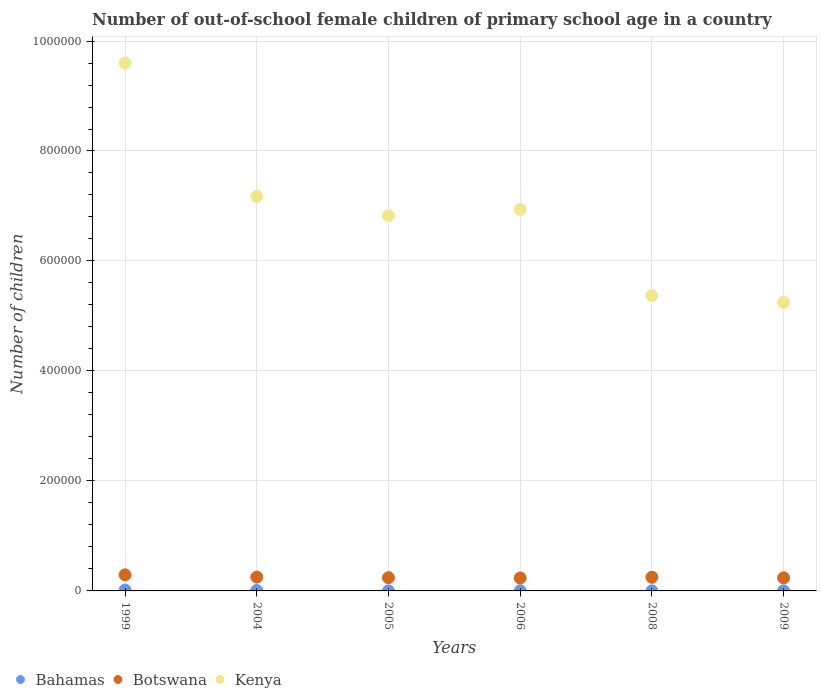Is the number of dotlines equal to the number of legend labels?
Provide a succinct answer. Yes. What is the number of out-of-school female children in Botswana in 2004?
Give a very brief answer. 2.52e+04. Across all years, what is the maximum number of out-of-school female children in Botswana?
Your answer should be compact. 2.92e+04. Across all years, what is the minimum number of out-of-school female children in Botswana?
Give a very brief answer. 2.36e+04. In which year was the number of out-of-school female children in Botswana maximum?
Provide a succinct answer. 1999. In which year was the number of out-of-school female children in Bahamas minimum?
Offer a terse response. 2005. What is the total number of out-of-school female children in Kenya in the graph?
Your answer should be compact. 4.12e+06. What is the difference between the number of out-of-school female children in Bahamas in 1999 and that in 2008?
Offer a very short reply. 1557. What is the difference between the number of out-of-school female children in Bahamas in 2006 and the number of out-of-school female children in Botswana in 2004?
Make the answer very short. -2.49e+04. What is the average number of out-of-school female children in Kenya per year?
Your response must be concise. 6.86e+05. In the year 2006, what is the difference between the number of out-of-school female children in Bahamas and number of out-of-school female children in Botswana?
Your answer should be very brief. -2.33e+04. What is the ratio of the number of out-of-school female children in Bahamas in 2004 to that in 2005?
Your answer should be compact. 34.7. Is the number of out-of-school female children in Kenya in 2004 less than that in 2006?
Keep it short and to the point. No. Is the difference between the number of out-of-school female children in Bahamas in 1999 and 2006 greater than the difference between the number of out-of-school female children in Botswana in 1999 and 2006?
Provide a short and direct response. No. What is the difference between the highest and the second highest number of out-of-school female children in Kenya?
Your answer should be very brief. 2.43e+05. What is the difference between the highest and the lowest number of out-of-school female children in Kenya?
Give a very brief answer. 4.35e+05. In how many years, is the number of out-of-school female children in Kenya greater than the average number of out-of-school female children in Kenya taken over all years?
Your response must be concise. 3. Is the sum of the number of out-of-school female children in Bahamas in 2004 and 2008 greater than the maximum number of out-of-school female children in Kenya across all years?
Offer a terse response. No. Is it the case that in every year, the sum of the number of out-of-school female children in Kenya and number of out-of-school female children in Bahamas  is greater than the number of out-of-school female children in Botswana?
Ensure brevity in your answer.  Yes. Is the number of out-of-school female children in Kenya strictly greater than the number of out-of-school female children in Bahamas over the years?
Make the answer very short. Yes. How many dotlines are there?
Make the answer very short. 3. How many legend labels are there?
Ensure brevity in your answer.  3. What is the title of the graph?
Your answer should be compact. Number of out-of-school female children of primary school age in a country. Does "Egypt, Arab Rep." appear as one of the legend labels in the graph?
Your response must be concise. No. What is the label or title of the X-axis?
Offer a very short reply. Years. What is the label or title of the Y-axis?
Give a very brief answer. Number of children. What is the Number of children in Bahamas in 1999?
Provide a succinct answer. 1607. What is the Number of children in Botswana in 1999?
Keep it short and to the point. 2.92e+04. What is the Number of children of Kenya in 1999?
Offer a terse response. 9.60e+05. What is the Number of children of Bahamas in 2004?
Ensure brevity in your answer.  798. What is the Number of children of Botswana in 2004?
Keep it short and to the point. 2.52e+04. What is the Number of children of Kenya in 2004?
Ensure brevity in your answer.  7.17e+05. What is the Number of children of Botswana in 2005?
Offer a very short reply. 2.40e+04. What is the Number of children of Kenya in 2005?
Your answer should be compact. 6.82e+05. What is the Number of children in Bahamas in 2006?
Offer a terse response. 241. What is the Number of children of Botswana in 2006?
Your answer should be compact. 2.36e+04. What is the Number of children in Kenya in 2006?
Offer a very short reply. 6.94e+05. What is the Number of children in Botswana in 2008?
Offer a very short reply. 2.48e+04. What is the Number of children of Kenya in 2008?
Make the answer very short. 5.37e+05. What is the Number of children of Bahamas in 2009?
Your answer should be very brief. 159. What is the Number of children of Botswana in 2009?
Your answer should be compact. 2.38e+04. What is the Number of children in Kenya in 2009?
Your answer should be very brief. 5.25e+05. Across all years, what is the maximum Number of children in Bahamas?
Ensure brevity in your answer.  1607. Across all years, what is the maximum Number of children in Botswana?
Your answer should be compact. 2.92e+04. Across all years, what is the maximum Number of children of Kenya?
Your response must be concise. 9.60e+05. Across all years, what is the minimum Number of children of Botswana?
Offer a very short reply. 2.36e+04. Across all years, what is the minimum Number of children of Kenya?
Your answer should be very brief. 5.25e+05. What is the total Number of children in Bahamas in the graph?
Give a very brief answer. 2878. What is the total Number of children in Botswana in the graph?
Give a very brief answer. 1.51e+05. What is the total Number of children in Kenya in the graph?
Your response must be concise. 4.12e+06. What is the difference between the Number of children in Bahamas in 1999 and that in 2004?
Offer a very short reply. 809. What is the difference between the Number of children of Botswana in 1999 and that in 2004?
Your response must be concise. 4097. What is the difference between the Number of children in Kenya in 1999 and that in 2004?
Offer a very short reply. 2.43e+05. What is the difference between the Number of children of Bahamas in 1999 and that in 2005?
Offer a very short reply. 1584. What is the difference between the Number of children of Botswana in 1999 and that in 2005?
Make the answer very short. 5205. What is the difference between the Number of children of Kenya in 1999 and that in 2005?
Keep it short and to the point. 2.78e+05. What is the difference between the Number of children of Bahamas in 1999 and that in 2006?
Your response must be concise. 1366. What is the difference between the Number of children in Botswana in 1999 and that in 2006?
Make the answer very short. 5678. What is the difference between the Number of children of Kenya in 1999 and that in 2006?
Keep it short and to the point. 2.66e+05. What is the difference between the Number of children in Bahamas in 1999 and that in 2008?
Ensure brevity in your answer.  1557. What is the difference between the Number of children in Botswana in 1999 and that in 2008?
Ensure brevity in your answer.  4397. What is the difference between the Number of children in Kenya in 1999 and that in 2008?
Ensure brevity in your answer.  4.23e+05. What is the difference between the Number of children of Bahamas in 1999 and that in 2009?
Offer a terse response. 1448. What is the difference between the Number of children of Botswana in 1999 and that in 2009?
Make the answer very short. 5470. What is the difference between the Number of children in Kenya in 1999 and that in 2009?
Your answer should be compact. 4.35e+05. What is the difference between the Number of children in Bahamas in 2004 and that in 2005?
Provide a succinct answer. 775. What is the difference between the Number of children in Botswana in 2004 and that in 2005?
Provide a succinct answer. 1108. What is the difference between the Number of children in Kenya in 2004 and that in 2005?
Your response must be concise. 3.51e+04. What is the difference between the Number of children of Bahamas in 2004 and that in 2006?
Ensure brevity in your answer.  557. What is the difference between the Number of children in Botswana in 2004 and that in 2006?
Give a very brief answer. 1581. What is the difference between the Number of children in Kenya in 2004 and that in 2006?
Give a very brief answer. 2.36e+04. What is the difference between the Number of children in Bahamas in 2004 and that in 2008?
Provide a short and direct response. 748. What is the difference between the Number of children in Botswana in 2004 and that in 2008?
Keep it short and to the point. 300. What is the difference between the Number of children of Kenya in 2004 and that in 2008?
Your answer should be very brief. 1.80e+05. What is the difference between the Number of children of Bahamas in 2004 and that in 2009?
Ensure brevity in your answer.  639. What is the difference between the Number of children in Botswana in 2004 and that in 2009?
Provide a succinct answer. 1373. What is the difference between the Number of children of Kenya in 2004 and that in 2009?
Provide a short and direct response. 1.93e+05. What is the difference between the Number of children of Bahamas in 2005 and that in 2006?
Offer a very short reply. -218. What is the difference between the Number of children in Botswana in 2005 and that in 2006?
Offer a terse response. 473. What is the difference between the Number of children of Kenya in 2005 and that in 2006?
Offer a very short reply. -1.16e+04. What is the difference between the Number of children in Bahamas in 2005 and that in 2008?
Your response must be concise. -27. What is the difference between the Number of children of Botswana in 2005 and that in 2008?
Your answer should be very brief. -808. What is the difference between the Number of children in Kenya in 2005 and that in 2008?
Your response must be concise. 1.45e+05. What is the difference between the Number of children in Bahamas in 2005 and that in 2009?
Your answer should be very brief. -136. What is the difference between the Number of children in Botswana in 2005 and that in 2009?
Give a very brief answer. 265. What is the difference between the Number of children in Kenya in 2005 and that in 2009?
Your answer should be compact. 1.57e+05. What is the difference between the Number of children of Bahamas in 2006 and that in 2008?
Ensure brevity in your answer.  191. What is the difference between the Number of children of Botswana in 2006 and that in 2008?
Provide a short and direct response. -1281. What is the difference between the Number of children of Kenya in 2006 and that in 2008?
Provide a short and direct response. 1.57e+05. What is the difference between the Number of children in Botswana in 2006 and that in 2009?
Provide a succinct answer. -208. What is the difference between the Number of children of Kenya in 2006 and that in 2009?
Give a very brief answer. 1.69e+05. What is the difference between the Number of children in Bahamas in 2008 and that in 2009?
Your answer should be compact. -109. What is the difference between the Number of children of Botswana in 2008 and that in 2009?
Your response must be concise. 1073. What is the difference between the Number of children in Kenya in 2008 and that in 2009?
Provide a succinct answer. 1.22e+04. What is the difference between the Number of children in Bahamas in 1999 and the Number of children in Botswana in 2004?
Your answer should be compact. -2.35e+04. What is the difference between the Number of children in Bahamas in 1999 and the Number of children in Kenya in 2004?
Offer a very short reply. -7.16e+05. What is the difference between the Number of children in Botswana in 1999 and the Number of children in Kenya in 2004?
Make the answer very short. -6.88e+05. What is the difference between the Number of children in Bahamas in 1999 and the Number of children in Botswana in 2005?
Give a very brief answer. -2.24e+04. What is the difference between the Number of children of Bahamas in 1999 and the Number of children of Kenya in 2005?
Your answer should be very brief. -6.81e+05. What is the difference between the Number of children of Botswana in 1999 and the Number of children of Kenya in 2005?
Your response must be concise. -6.53e+05. What is the difference between the Number of children of Bahamas in 1999 and the Number of children of Botswana in 2006?
Keep it short and to the point. -2.20e+04. What is the difference between the Number of children in Bahamas in 1999 and the Number of children in Kenya in 2006?
Your answer should be very brief. -6.92e+05. What is the difference between the Number of children in Botswana in 1999 and the Number of children in Kenya in 2006?
Ensure brevity in your answer.  -6.65e+05. What is the difference between the Number of children of Bahamas in 1999 and the Number of children of Botswana in 2008?
Offer a very short reply. -2.32e+04. What is the difference between the Number of children of Bahamas in 1999 and the Number of children of Kenya in 2008?
Offer a very short reply. -5.35e+05. What is the difference between the Number of children in Botswana in 1999 and the Number of children in Kenya in 2008?
Make the answer very short. -5.08e+05. What is the difference between the Number of children of Bahamas in 1999 and the Number of children of Botswana in 2009?
Your answer should be very brief. -2.22e+04. What is the difference between the Number of children in Bahamas in 1999 and the Number of children in Kenya in 2009?
Provide a succinct answer. -5.23e+05. What is the difference between the Number of children in Botswana in 1999 and the Number of children in Kenya in 2009?
Your answer should be compact. -4.96e+05. What is the difference between the Number of children in Bahamas in 2004 and the Number of children in Botswana in 2005?
Keep it short and to the point. -2.32e+04. What is the difference between the Number of children in Bahamas in 2004 and the Number of children in Kenya in 2005?
Give a very brief answer. -6.81e+05. What is the difference between the Number of children in Botswana in 2004 and the Number of children in Kenya in 2005?
Ensure brevity in your answer.  -6.57e+05. What is the difference between the Number of children in Bahamas in 2004 and the Number of children in Botswana in 2006?
Your response must be concise. -2.28e+04. What is the difference between the Number of children in Bahamas in 2004 and the Number of children in Kenya in 2006?
Offer a very short reply. -6.93e+05. What is the difference between the Number of children in Botswana in 2004 and the Number of children in Kenya in 2006?
Your answer should be very brief. -6.69e+05. What is the difference between the Number of children in Bahamas in 2004 and the Number of children in Botswana in 2008?
Your answer should be compact. -2.41e+04. What is the difference between the Number of children in Bahamas in 2004 and the Number of children in Kenya in 2008?
Give a very brief answer. -5.36e+05. What is the difference between the Number of children in Botswana in 2004 and the Number of children in Kenya in 2008?
Make the answer very short. -5.12e+05. What is the difference between the Number of children in Bahamas in 2004 and the Number of children in Botswana in 2009?
Ensure brevity in your answer.  -2.30e+04. What is the difference between the Number of children of Bahamas in 2004 and the Number of children of Kenya in 2009?
Provide a succinct answer. -5.24e+05. What is the difference between the Number of children of Botswana in 2004 and the Number of children of Kenya in 2009?
Offer a very short reply. -5.00e+05. What is the difference between the Number of children of Bahamas in 2005 and the Number of children of Botswana in 2006?
Give a very brief answer. -2.35e+04. What is the difference between the Number of children of Bahamas in 2005 and the Number of children of Kenya in 2006?
Ensure brevity in your answer.  -6.94e+05. What is the difference between the Number of children of Botswana in 2005 and the Number of children of Kenya in 2006?
Make the answer very short. -6.70e+05. What is the difference between the Number of children of Bahamas in 2005 and the Number of children of Botswana in 2008?
Give a very brief answer. -2.48e+04. What is the difference between the Number of children of Bahamas in 2005 and the Number of children of Kenya in 2008?
Offer a terse response. -5.37e+05. What is the difference between the Number of children in Botswana in 2005 and the Number of children in Kenya in 2008?
Keep it short and to the point. -5.13e+05. What is the difference between the Number of children in Bahamas in 2005 and the Number of children in Botswana in 2009?
Ensure brevity in your answer.  -2.38e+04. What is the difference between the Number of children in Bahamas in 2005 and the Number of children in Kenya in 2009?
Provide a short and direct response. -5.25e+05. What is the difference between the Number of children of Botswana in 2005 and the Number of children of Kenya in 2009?
Offer a very short reply. -5.01e+05. What is the difference between the Number of children in Bahamas in 2006 and the Number of children in Botswana in 2008?
Your response must be concise. -2.46e+04. What is the difference between the Number of children in Bahamas in 2006 and the Number of children in Kenya in 2008?
Make the answer very short. -5.37e+05. What is the difference between the Number of children of Botswana in 2006 and the Number of children of Kenya in 2008?
Keep it short and to the point. -5.13e+05. What is the difference between the Number of children in Bahamas in 2006 and the Number of children in Botswana in 2009?
Offer a very short reply. -2.35e+04. What is the difference between the Number of children in Bahamas in 2006 and the Number of children in Kenya in 2009?
Keep it short and to the point. -5.25e+05. What is the difference between the Number of children of Botswana in 2006 and the Number of children of Kenya in 2009?
Make the answer very short. -5.01e+05. What is the difference between the Number of children of Bahamas in 2008 and the Number of children of Botswana in 2009?
Your answer should be very brief. -2.37e+04. What is the difference between the Number of children in Bahamas in 2008 and the Number of children in Kenya in 2009?
Provide a succinct answer. -5.25e+05. What is the difference between the Number of children of Botswana in 2008 and the Number of children of Kenya in 2009?
Your answer should be compact. -5.00e+05. What is the average Number of children in Bahamas per year?
Provide a short and direct response. 479.67. What is the average Number of children of Botswana per year?
Your answer should be very brief. 2.51e+04. What is the average Number of children in Kenya per year?
Provide a short and direct response. 6.86e+05. In the year 1999, what is the difference between the Number of children in Bahamas and Number of children in Botswana?
Provide a short and direct response. -2.76e+04. In the year 1999, what is the difference between the Number of children of Bahamas and Number of children of Kenya?
Keep it short and to the point. -9.58e+05. In the year 1999, what is the difference between the Number of children in Botswana and Number of children in Kenya?
Your answer should be compact. -9.31e+05. In the year 2004, what is the difference between the Number of children of Bahamas and Number of children of Botswana?
Offer a terse response. -2.44e+04. In the year 2004, what is the difference between the Number of children in Bahamas and Number of children in Kenya?
Provide a succinct answer. -7.17e+05. In the year 2004, what is the difference between the Number of children in Botswana and Number of children in Kenya?
Keep it short and to the point. -6.92e+05. In the year 2005, what is the difference between the Number of children in Bahamas and Number of children in Botswana?
Offer a very short reply. -2.40e+04. In the year 2005, what is the difference between the Number of children in Bahamas and Number of children in Kenya?
Your response must be concise. -6.82e+05. In the year 2005, what is the difference between the Number of children in Botswana and Number of children in Kenya?
Your answer should be compact. -6.58e+05. In the year 2006, what is the difference between the Number of children in Bahamas and Number of children in Botswana?
Keep it short and to the point. -2.33e+04. In the year 2006, what is the difference between the Number of children in Bahamas and Number of children in Kenya?
Give a very brief answer. -6.94e+05. In the year 2006, what is the difference between the Number of children of Botswana and Number of children of Kenya?
Your answer should be very brief. -6.70e+05. In the year 2008, what is the difference between the Number of children of Bahamas and Number of children of Botswana?
Your answer should be compact. -2.48e+04. In the year 2008, what is the difference between the Number of children of Bahamas and Number of children of Kenya?
Your answer should be very brief. -5.37e+05. In the year 2008, what is the difference between the Number of children of Botswana and Number of children of Kenya?
Offer a terse response. -5.12e+05. In the year 2009, what is the difference between the Number of children in Bahamas and Number of children in Botswana?
Offer a terse response. -2.36e+04. In the year 2009, what is the difference between the Number of children of Bahamas and Number of children of Kenya?
Make the answer very short. -5.25e+05. In the year 2009, what is the difference between the Number of children of Botswana and Number of children of Kenya?
Offer a very short reply. -5.01e+05. What is the ratio of the Number of children of Bahamas in 1999 to that in 2004?
Keep it short and to the point. 2.01. What is the ratio of the Number of children in Botswana in 1999 to that in 2004?
Your answer should be very brief. 1.16. What is the ratio of the Number of children of Kenya in 1999 to that in 2004?
Offer a terse response. 1.34. What is the ratio of the Number of children in Bahamas in 1999 to that in 2005?
Give a very brief answer. 69.87. What is the ratio of the Number of children in Botswana in 1999 to that in 2005?
Provide a succinct answer. 1.22. What is the ratio of the Number of children of Kenya in 1999 to that in 2005?
Your answer should be compact. 1.41. What is the ratio of the Number of children in Bahamas in 1999 to that in 2006?
Your response must be concise. 6.67. What is the ratio of the Number of children of Botswana in 1999 to that in 2006?
Your answer should be very brief. 1.24. What is the ratio of the Number of children in Kenya in 1999 to that in 2006?
Provide a short and direct response. 1.38. What is the ratio of the Number of children of Bahamas in 1999 to that in 2008?
Give a very brief answer. 32.14. What is the ratio of the Number of children of Botswana in 1999 to that in 2008?
Keep it short and to the point. 1.18. What is the ratio of the Number of children in Kenya in 1999 to that in 2008?
Make the answer very short. 1.79. What is the ratio of the Number of children in Bahamas in 1999 to that in 2009?
Give a very brief answer. 10.11. What is the ratio of the Number of children of Botswana in 1999 to that in 2009?
Your answer should be compact. 1.23. What is the ratio of the Number of children in Kenya in 1999 to that in 2009?
Make the answer very short. 1.83. What is the ratio of the Number of children of Bahamas in 2004 to that in 2005?
Ensure brevity in your answer.  34.7. What is the ratio of the Number of children in Botswana in 2004 to that in 2005?
Your answer should be very brief. 1.05. What is the ratio of the Number of children in Kenya in 2004 to that in 2005?
Offer a very short reply. 1.05. What is the ratio of the Number of children in Bahamas in 2004 to that in 2006?
Your answer should be very brief. 3.31. What is the ratio of the Number of children of Botswana in 2004 to that in 2006?
Offer a very short reply. 1.07. What is the ratio of the Number of children of Kenya in 2004 to that in 2006?
Keep it short and to the point. 1.03. What is the ratio of the Number of children of Bahamas in 2004 to that in 2008?
Your answer should be very brief. 15.96. What is the ratio of the Number of children in Botswana in 2004 to that in 2008?
Your response must be concise. 1.01. What is the ratio of the Number of children of Kenya in 2004 to that in 2008?
Give a very brief answer. 1.34. What is the ratio of the Number of children of Bahamas in 2004 to that in 2009?
Make the answer very short. 5.02. What is the ratio of the Number of children in Botswana in 2004 to that in 2009?
Provide a short and direct response. 1.06. What is the ratio of the Number of children of Kenya in 2004 to that in 2009?
Keep it short and to the point. 1.37. What is the ratio of the Number of children of Bahamas in 2005 to that in 2006?
Ensure brevity in your answer.  0.1. What is the ratio of the Number of children in Botswana in 2005 to that in 2006?
Keep it short and to the point. 1.02. What is the ratio of the Number of children of Kenya in 2005 to that in 2006?
Your response must be concise. 0.98. What is the ratio of the Number of children of Bahamas in 2005 to that in 2008?
Offer a very short reply. 0.46. What is the ratio of the Number of children in Botswana in 2005 to that in 2008?
Offer a very short reply. 0.97. What is the ratio of the Number of children of Kenya in 2005 to that in 2008?
Your response must be concise. 1.27. What is the ratio of the Number of children in Bahamas in 2005 to that in 2009?
Provide a short and direct response. 0.14. What is the ratio of the Number of children in Botswana in 2005 to that in 2009?
Your answer should be very brief. 1.01. What is the ratio of the Number of children in Kenya in 2005 to that in 2009?
Ensure brevity in your answer.  1.3. What is the ratio of the Number of children in Bahamas in 2006 to that in 2008?
Provide a succinct answer. 4.82. What is the ratio of the Number of children of Botswana in 2006 to that in 2008?
Ensure brevity in your answer.  0.95. What is the ratio of the Number of children of Kenya in 2006 to that in 2008?
Provide a succinct answer. 1.29. What is the ratio of the Number of children of Bahamas in 2006 to that in 2009?
Give a very brief answer. 1.52. What is the ratio of the Number of children of Botswana in 2006 to that in 2009?
Your response must be concise. 0.99. What is the ratio of the Number of children in Kenya in 2006 to that in 2009?
Provide a short and direct response. 1.32. What is the ratio of the Number of children of Bahamas in 2008 to that in 2009?
Provide a short and direct response. 0.31. What is the ratio of the Number of children in Botswana in 2008 to that in 2009?
Your answer should be compact. 1.05. What is the ratio of the Number of children in Kenya in 2008 to that in 2009?
Give a very brief answer. 1.02. What is the difference between the highest and the second highest Number of children in Bahamas?
Your response must be concise. 809. What is the difference between the highest and the second highest Number of children in Botswana?
Offer a very short reply. 4097. What is the difference between the highest and the second highest Number of children of Kenya?
Provide a short and direct response. 2.43e+05. What is the difference between the highest and the lowest Number of children in Bahamas?
Ensure brevity in your answer.  1584. What is the difference between the highest and the lowest Number of children of Botswana?
Ensure brevity in your answer.  5678. What is the difference between the highest and the lowest Number of children of Kenya?
Give a very brief answer. 4.35e+05. 